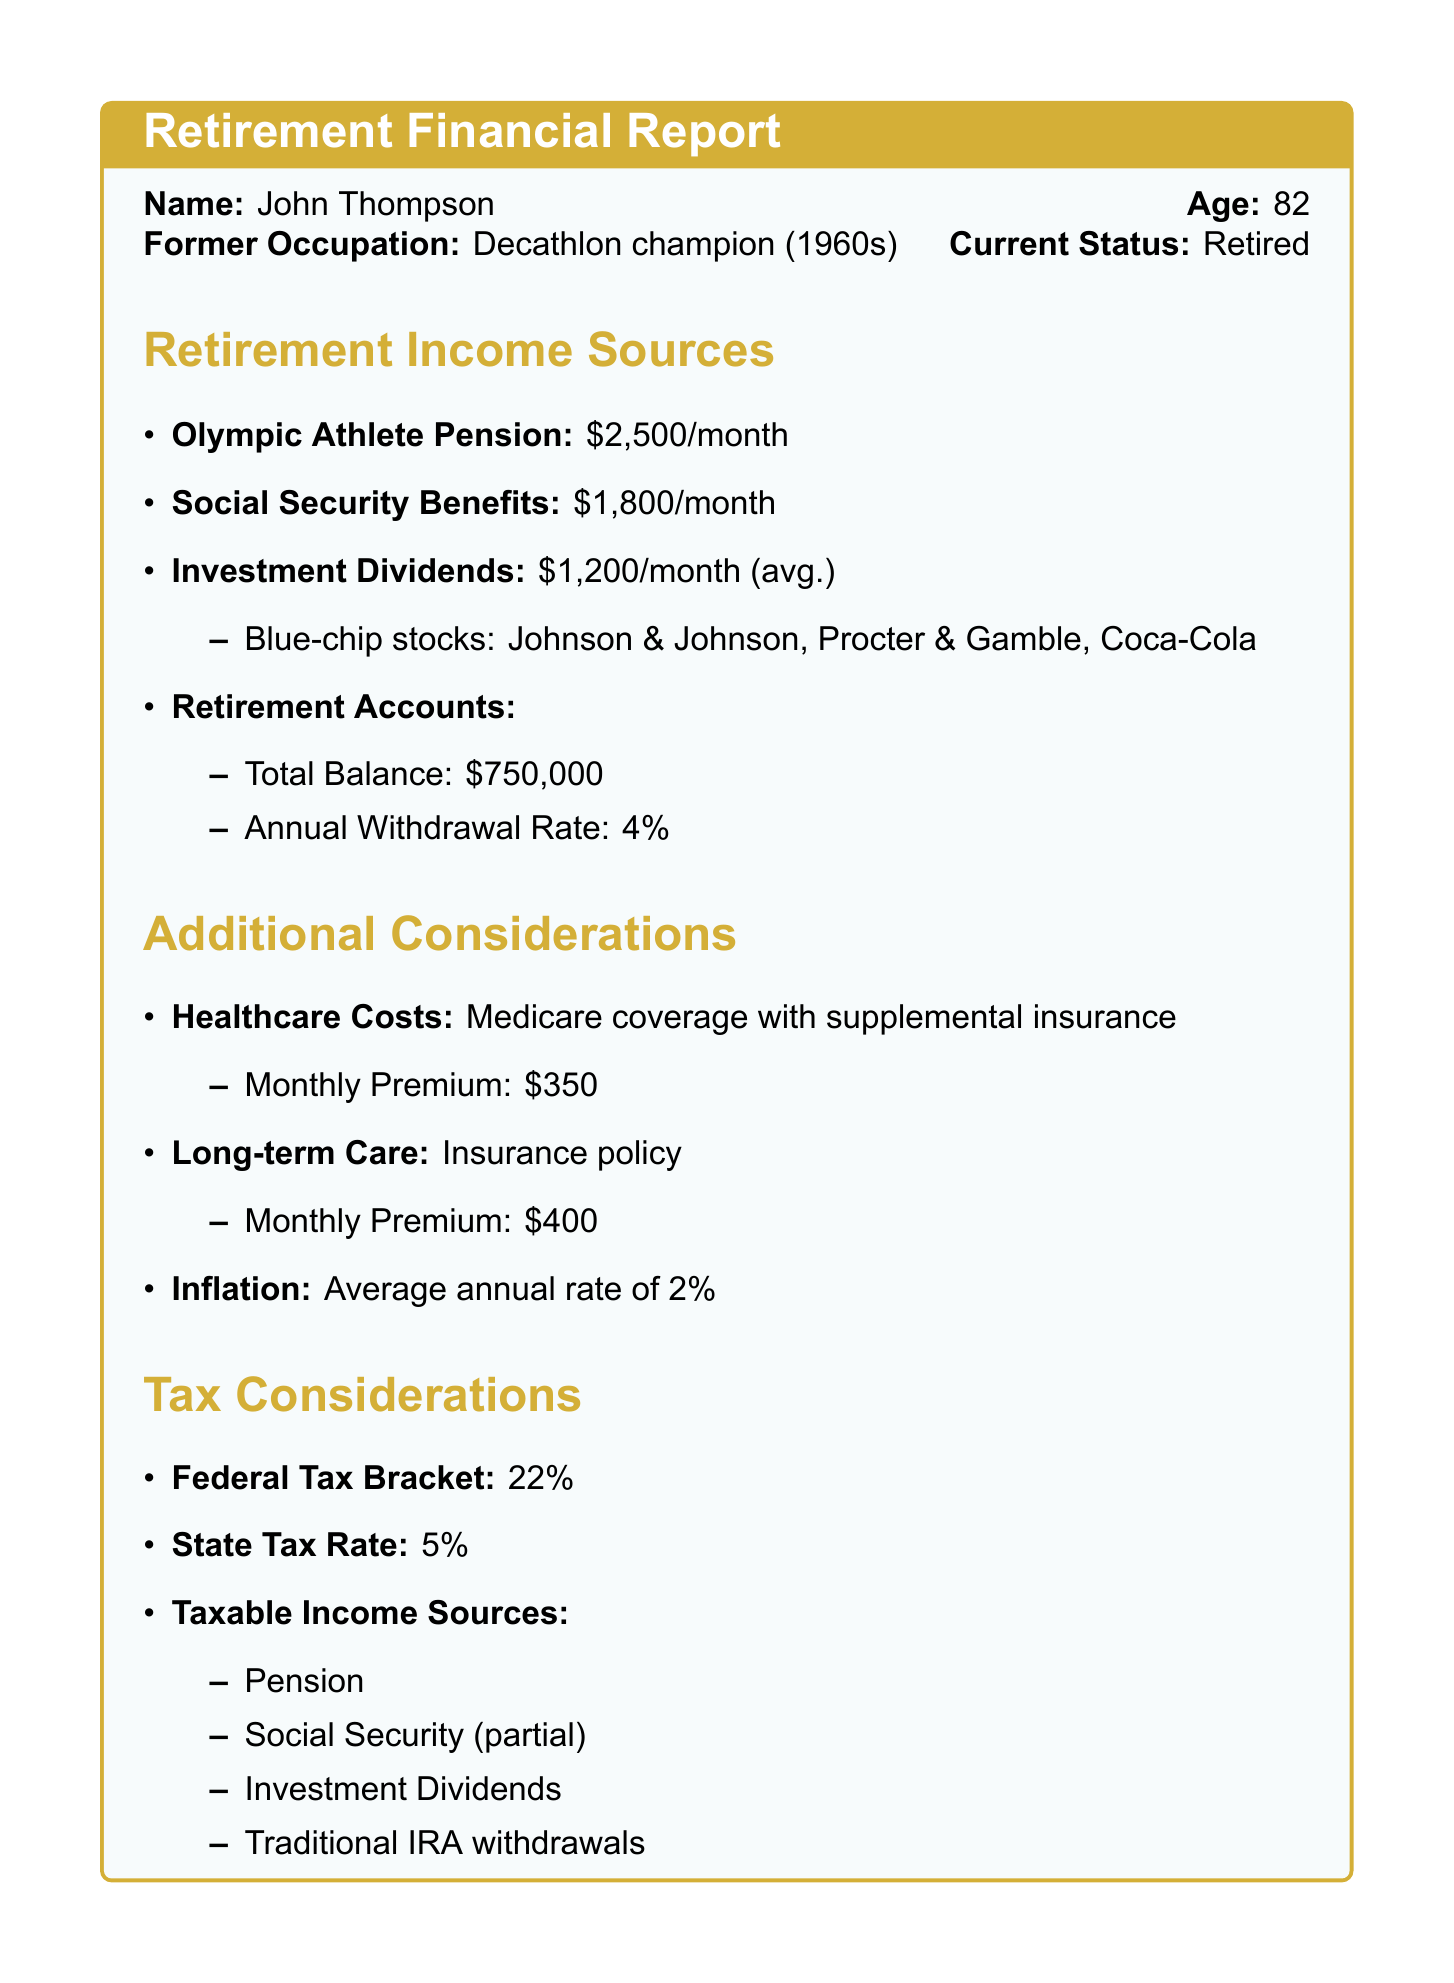What is the monthly amount received from the Olympic Athlete Pension? The Olympic Athlete Pension provides a monthly amount of $2500 as per the document.
Answer: $2500 What is the total balance of retirement accounts? The total balance of retirement accounts mentioned in the document is $750,000.
Answer: $750,000 How much is collected monthly from Social Security benefits? The document states that the monthly Social Security benefits amount to $1800.
Answer: $1800 What is the annual withdrawal rate from the retirement accounts? The annual withdrawal rate from the retirement accounts is specified as 4% in the document.
Answer: 4% What are the monthly premiums for Long-term Care? The document states that the monthly premium for Long-term Care insurance is $400.
Answer: $400 What is the combined monthly income from pension and Social Security benefits? The combined monthly income from pension ($2500) and Social Security ($1800) is calculated as $2500 + $1800 = $4300.
Answer: $4300 What type of stocks does the investment dividends portfolio focus on? The investment dividends portfolio focuses on blue-chip stocks according to the information in the document.
Answer: Blue-chip stocks What is the federal tax bracket mentioned in the document? The document indicates that the federal tax bracket is 22%.
Answer: 22% Which factors are included in the additional considerations section? The additional considerations section includes healthcare costs, long-term care, and inflation as factors.
Answer: Healthcare costs, long-term care, inflation 